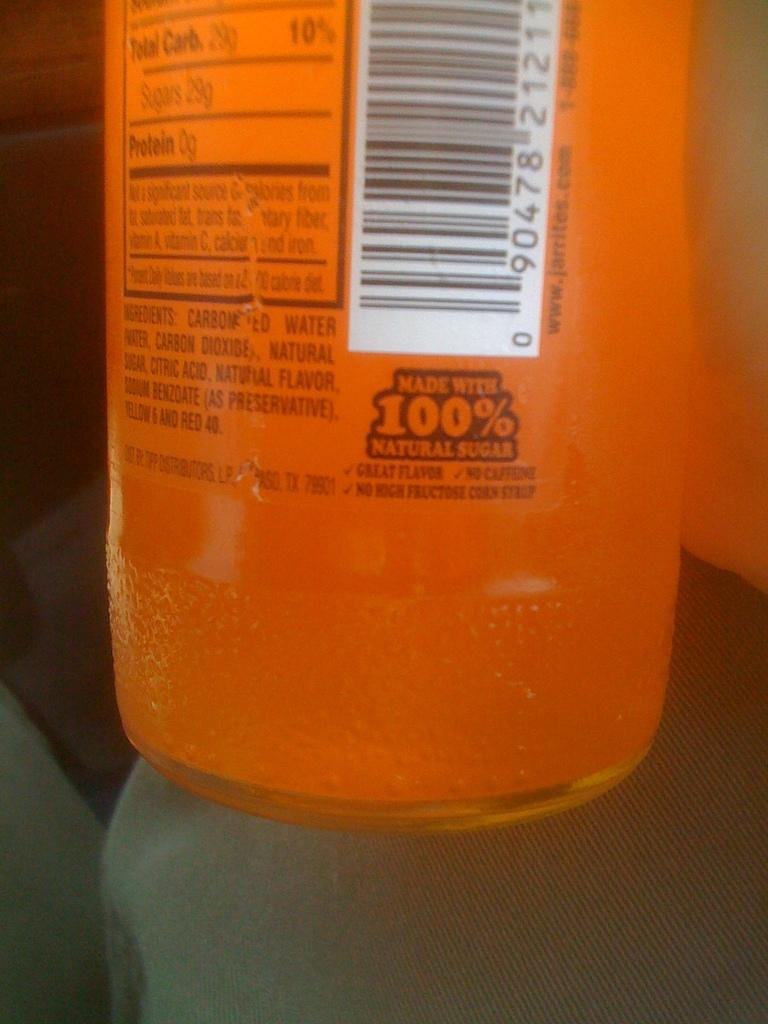<image>
Offer a succinct explanation of the picture presented. A bottle of liquid that says 100% natural sugar. 